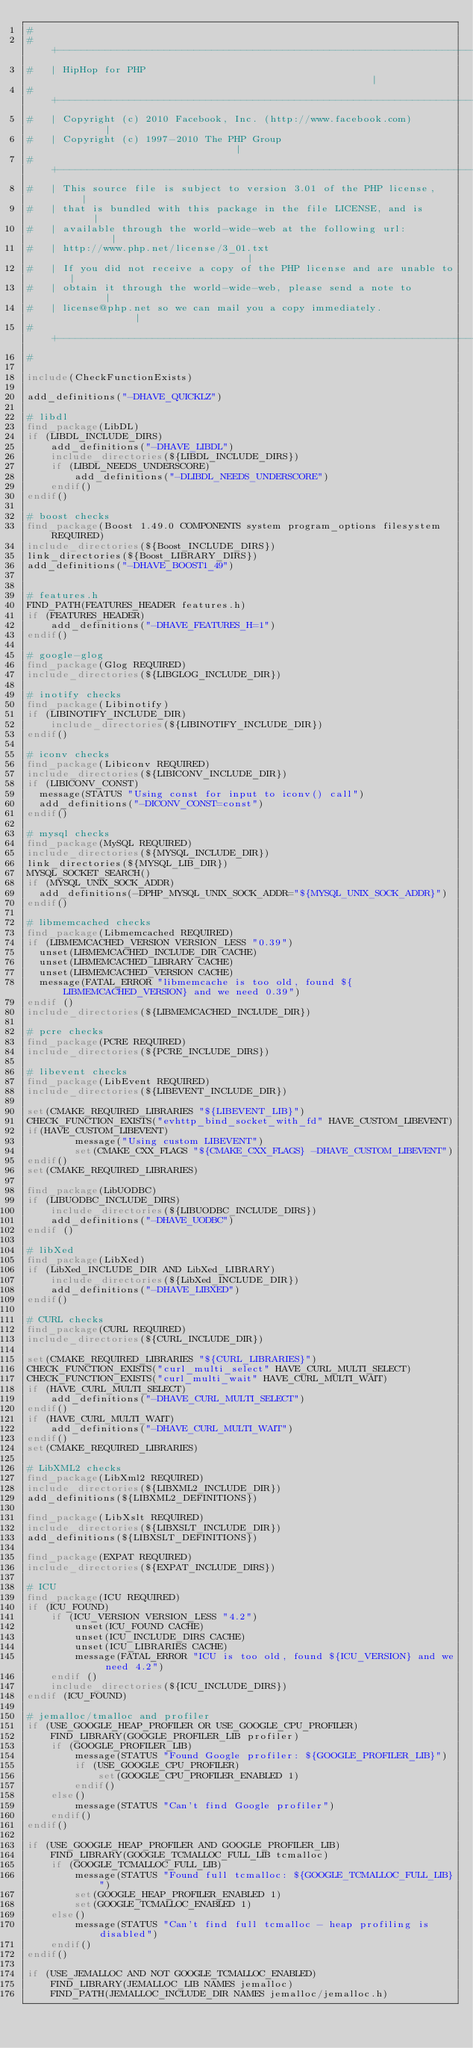<code> <loc_0><loc_0><loc_500><loc_500><_CMake_>#
#   +----------------------------------------------------------------------+
#   | HipHop for PHP                                                       |
#   +----------------------------------------------------------------------+
#   | Copyright (c) 2010 Facebook, Inc. (http://www.facebook.com)          |
#   | Copyright (c) 1997-2010 The PHP Group                                |
#   +----------------------------------------------------------------------+
#   | This source file is subject to version 3.01 of the PHP license,      |
#   | that is bundled with this package in the file LICENSE, and is        |
#   | available through the world-wide-web at the following url:           |
#   | http://www.php.net/license/3_01.txt                                  |
#   | If you did not receive a copy of the PHP license and are unable to   |
#   | obtain it through the world-wide-web, please send a note to          |
#   | license@php.net so we can mail you a copy immediately.               |
#   +----------------------------------------------------------------------+
#

include(CheckFunctionExists)

add_definitions("-DHAVE_QUICKLZ")

# libdl
find_package(LibDL)
if (LIBDL_INCLUDE_DIRS)
	add_definitions("-DHAVE_LIBDL")
	include_directories(${LIBDL_INCLUDE_DIRS})
	if (LIBDL_NEEDS_UNDERSCORE)
		add_definitions("-DLIBDL_NEEDS_UNDERSCORE")
	endif()
endif()

# boost checks
find_package(Boost 1.49.0 COMPONENTS system program_options filesystem REQUIRED)
include_directories(${Boost_INCLUDE_DIRS})
link_directories(${Boost_LIBRARY_DIRS})
add_definitions("-DHAVE_BOOST1_49")


# features.h
FIND_PATH(FEATURES_HEADER features.h)
if (FEATURES_HEADER)
	add_definitions("-DHAVE_FEATURES_H=1")
endif()

# google-glog
find_package(Glog REQUIRED)
include_directories(${LIBGLOG_INCLUDE_DIR})

# inotify checks
find_package(Libinotify)
if (LIBINOTIFY_INCLUDE_DIR)
	include_directories(${LIBINOTIFY_INCLUDE_DIR})
endif()

# iconv checks
find_package(Libiconv REQUIRED)
include_directories(${LIBICONV_INCLUDE_DIR})
if (LIBICONV_CONST)
  message(STATUS "Using const for input to iconv() call")
  add_definitions("-DICONV_CONST=const")
endif()

# mysql checks
find_package(MySQL REQUIRED)
include_directories(${MYSQL_INCLUDE_DIR})
link_directories(${MYSQL_LIB_DIR})
MYSQL_SOCKET_SEARCH()
if (MYSQL_UNIX_SOCK_ADDR)
  add_definitions(-DPHP_MYSQL_UNIX_SOCK_ADDR="${MYSQL_UNIX_SOCK_ADDR}")
endif()

# libmemcached checks
find_package(Libmemcached REQUIRED)
if (LIBMEMCACHED_VERSION VERSION_LESS "0.39")
  unset(LIBMEMCACHED_INCLUDE_DIR CACHE)
  unset(LIBMEMCACHED_LIBRARY CACHE)
  unset(LIBMEMCACHED_VERSION CACHE)
  message(FATAL_ERROR "libmemcache is too old, found ${LIBMEMCACHED_VERSION} and we need 0.39")
endif ()
include_directories(${LIBMEMCACHED_INCLUDE_DIR})

# pcre checks
find_package(PCRE REQUIRED)
include_directories(${PCRE_INCLUDE_DIRS})

# libevent checks
find_package(LibEvent REQUIRED)
include_directories(${LIBEVENT_INCLUDE_DIR})

set(CMAKE_REQUIRED_LIBRARIES "${LIBEVENT_LIB}")
CHECK_FUNCTION_EXISTS("evhttp_bind_socket_with_fd" HAVE_CUSTOM_LIBEVENT)
if(HAVE_CUSTOM_LIBEVENT)
        message("Using custom LIBEVENT")
        set(CMAKE_CXX_FLAGS "${CMAKE_CXX_FLAGS} -DHAVE_CUSTOM_LIBEVENT")
endif()
set(CMAKE_REQUIRED_LIBRARIES)

find_package(LibUODBC)
if (LIBUODBC_INCLUDE_DIRS)
	include_directories(${LIBUODBC_INCLUDE_DIRS})
	add_definitions("-DHAVE_UODBC")
endif ()

# libXed
find_package(LibXed)
if (LibXed_INCLUDE_DIR AND LibXed_LIBRARY)
	include_directories(${LibXed_INCLUDE_DIR})
	add_definitions("-DHAVE_LIBXED")
endif()

# CURL checks
find_package(CURL REQUIRED)
include_directories(${CURL_INCLUDE_DIR})

set(CMAKE_REQUIRED_LIBRARIES "${CURL_LIBRARIES}")
CHECK_FUNCTION_EXISTS("curl_multi_select" HAVE_CURL_MULTI_SELECT)
CHECK_FUNCTION_EXISTS("curl_multi_wait" HAVE_CURL_MULTI_WAIT)
if (HAVE_CURL_MULTI_SELECT)
	add_definitions("-DHAVE_CURL_MULTI_SELECT")
endif()
if (HAVE_CURL_MULTI_WAIT)
	add_definitions("-DHAVE_CURL_MULTI_WAIT")
endif()
set(CMAKE_REQUIRED_LIBRARIES)

# LibXML2 checks
find_package(LibXml2 REQUIRED)
include_directories(${LIBXML2_INCLUDE_DIR})
add_definitions(${LIBXML2_DEFINITIONS})

find_package(LibXslt REQUIRED)
include_directories(${LIBXSLT_INCLUDE_DIR})
add_definitions(${LIBXSLT_DEFINITIONS})

find_package(EXPAT REQUIRED)
include_directories(${EXPAT_INCLUDE_DIRS})

# ICU
find_package(ICU REQUIRED)
if (ICU_FOUND)
	if (ICU_VERSION VERSION_LESS "4.2")
		unset(ICU_FOUND CACHE)
		unset(ICU_INCLUDE_DIRS CACHE)
		unset(ICU_LIBRARIES CACHE)
		message(FATAL_ERROR "ICU is too old, found ${ICU_VERSION} and we need 4.2")
	endif ()
	include_directories(${ICU_INCLUDE_DIRS})
endif (ICU_FOUND)

# jemalloc/tmalloc and profiler
if (USE_GOOGLE_HEAP_PROFILER OR USE_GOOGLE_CPU_PROFILER)
	FIND_LIBRARY(GOOGLE_PROFILER_LIB profiler)
	if (GOOGLE_PROFILER_LIB)
		message(STATUS "Found Google profiler: ${GOOGLE_PROFILER_LIB}")
		if (USE_GOOGLE_CPU_PROFILER)
			set(GOOGLE_CPU_PROFILER_ENABLED 1)
		endif()
	else()
		message(STATUS "Can't find Google profiler")
	endif()
endif()

if (USE_GOOGLE_HEAP_PROFILER AND GOOGLE_PROFILER_LIB)
	FIND_LIBRARY(GOOGLE_TCMALLOC_FULL_LIB tcmalloc)
	if (GOOGLE_TCMALLOC_FULL_LIB)
		message(STATUS "Found full tcmalloc: ${GOOGLE_TCMALLOC_FULL_LIB}")
		set(GOOGLE_HEAP_PROFILER_ENABLED 1)
		set(GOOGLE_TCMALLOC_ENABLED 1)
	else()
		message(STATUS "Can't find full tcmalloc - heap profiling is disabled")
	endif()
endif()

if (USE_JEMALLOC AND NOT GOOGLE_TCMALLOC_ENABLED)
	FIND_LIBRARY(JEMALLOC_LIB NAMES jemalloc)
	FIND_PATH(JEMALLOC_INCLUDE_DIR NAMES jemalloc/jemalloc.h)
</code> 